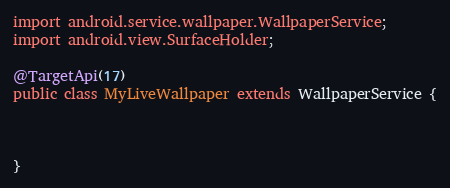<code> <loc_0><loc_0><loc_500><loc_500><_Java_>import android.service.wallpaper.WallpaperService;
import android.view.SurfaceHolder;

@TargetApi(17)
public class MyLiveWallpaper extends WallpaperService {



}</code> 